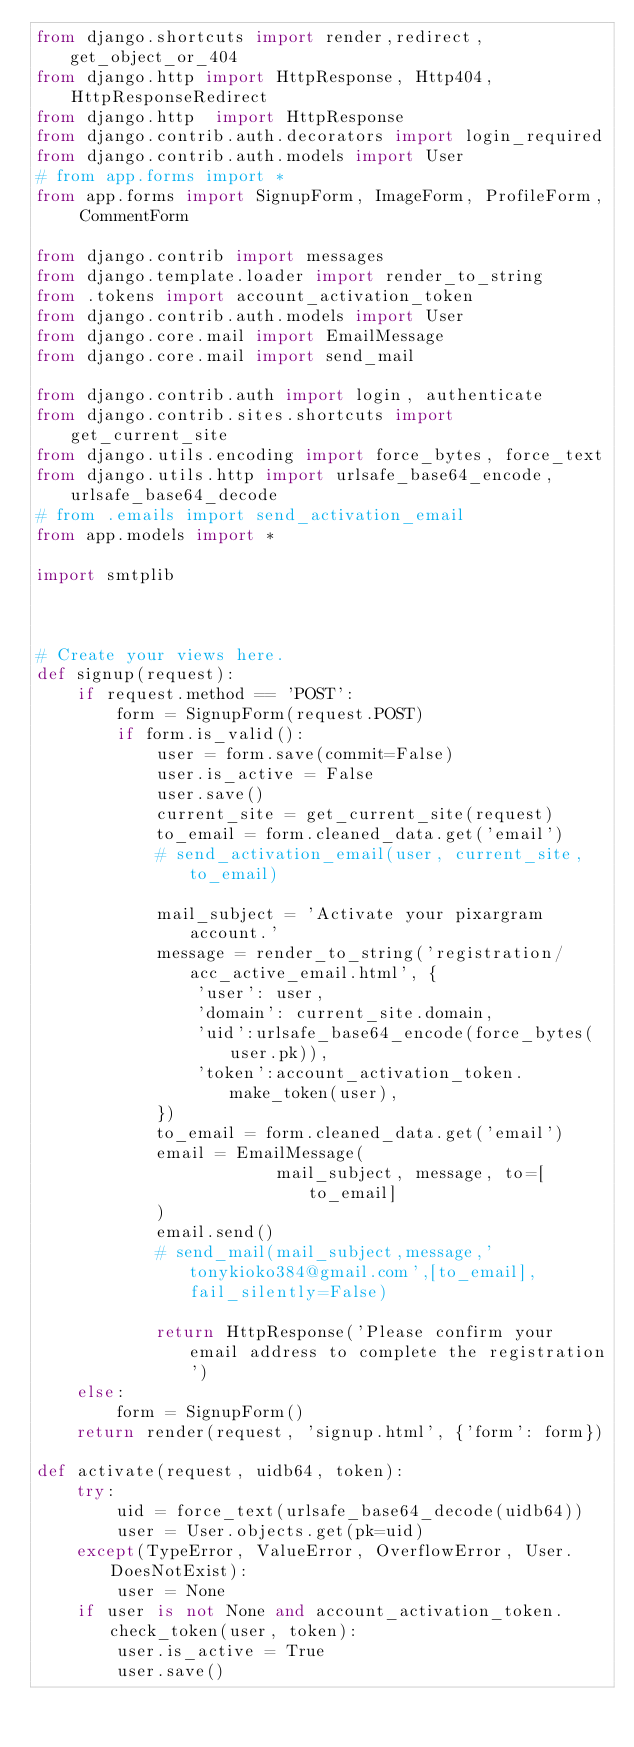<code> <loc_0><loc_0><loc_500><loc_500><_Python_>from django.shortcuts import render,redirect,get_object_or_404
from django.http import HttpResponse, Http404,HttpResponseRedirect
from django.http  import HttpResponse
from django.contrib.auth.decorators import login_required
from django.contrib.auth.models import User
# from app.forms import *
from app.forms import SignupForm, ImageForm, ProfileForm, CommentForm

from django.contrib import messages
from django.template.loader import render_to_string
from .tokens import account_activation_token
from django.contrib.auth.models import User
from django.core.mail import EmailMessage
from django.core.mail import send_mail

from django.contrib.auth import login, authenticate
from django.contrib.sites.shortcuts import get_current_site
from django.utils.encoding import force_bytes, force_text
from django.utils.http import urlsafe_base64_encode, urlsafe_base64_decode
# from .emails import send_activation_email
from app.models import *

import smtplib



# Create your views here.
def signup(request):
    if request.method == 'POST':
        form = SignupForm(request.POST)
        if form.is_valid():
            user = form.save(commit=False)
            user.is_active = False
            user.save()
            current_site = get_current_site(request)
            to_email = form.cleaned_data.get('email')
            # send_activation_email(user, current_site, to_email)

            mail_subject = 'Activate your pixargram account.'
            message = render_to_string('registration/acc_active_email.html', {
                'user': user,
                'domain': current_site.domain,
                'uid':urlsafe_base64_encode(force_bytes(user.pk)),
                'token':account_activation_token.make_token(user),
            })
            to_email = form.cleaned_data.get('email')
            email = EmailMessage(
                        mail_subject, message, to=[to_email]
            )
            email.send()
            # send_mail(mail_subject,message,'tonykioko384@gmail.com',[to_email],fail_silently=False)

            return HttpResponse('Please confirm your email address to complete the registration')
    else:
        form = SignupForm()
    return render(request, 'signup.html', {'form': form})

def activate(request, uidb64, token):
    try:
        uid = force_text(urlsafe_base64_decode(uidb64))
        user = User.objects.get(pk=uid)
    except(TypeError, ValueError, OverflowError, User.DoesNotExist):
        user = None
    if user is not None and account_activation_token.check_token(user, token):
        user.is_active = True
        user.save()</code> 